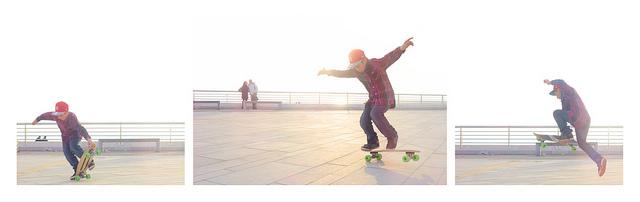Is this taking place indoors?
Keep it brief. No. What color baseball cap is this person wearing?
Give a very brief answer. Red. Why is the action in the photo on the far right dangerous?
Give a very brief answer. Because you can break leg. 